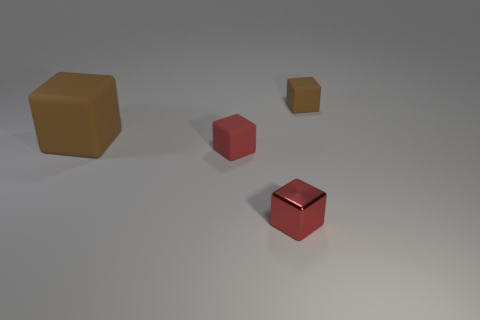What number of things are yellow metallic balls or tiny red metal cubes?
Keep it short and to the point. 1. How many red blocks are to the left of the red object that is on the left side of the small red thing in front of the small red rubber cube?
Provide a succinct answer. 0. Is there any other thing that has the same color as the large block?
Offer a terse response. Yes. There is a tiny thing left of the red metal cube; is it the same color as the matte thing to the right of the small red shiny thing?
Provide a succinct answer. No. Are there more red shiny cubes to the right of the red shiny block than red blocks that are left of the tiny red rubber cube?
Your response must be concise. No. What is the material of the big brown block?
Provide a succinct answer. Rubber. What is the shape of the tiny matte object that is left of the small cube behind the brown rubber cube that is in front of the small brown cube?
Provide a short and direct response. Cube. What number of other objects are there of the same material as the tiny brown object?
Make the answer very short. 2. Is the brown block that is left of the tiny metallic cube made of the same material as the small block that is on the right side of the red metal object?
Your answer should be very brief. Yes. What number of tiny matte cubes are in front of the large brown thing and behind the large matte cube?
Your response must be concise. 0. 